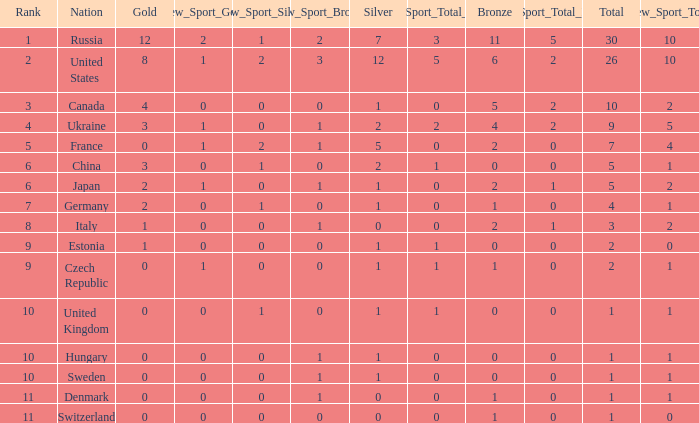Parse the table in full. {'header': ['Rank', 'Nation', 'Gold', 'New_Sport_Gold', 'New_Sport_Silver', 'New_Sport_Bronze', 'Silver', 'New_Sport_Total_Silver', 'Bronze', 'New_Sport_Total_Bronze', 'Total', 'New_Sport_Total'], 'rows': [['1', 'Russia', '12', '2', '1', '2', '7', '3', '11', '5', '30', '10'], ['2', 'United States', '8', '1', '2', '3', '12', '5', '6', '2', '26', '10'], ['3', 'Canada', '4', '0', '0', '0', '1', '0', '5', '2', '10', '2'], ['4', 'Ukraine', '3', '1', '0', '1', '2', '2', '4', '2', '9', '5'], ['5', 'France', '0', '1', '2', '1', '5', '0', '2', '0', '7', '4'], ['6', 'China', '3', '0', '1', '0', '2', '1', '0', '0', '5', '1'], ['6', 'Japan', '2', '1', '0', '1', '1', '0', '2', '1', '5', '2'], ['7', 'Germany', '2', '0', '1', '0', '1', '0', '1', '0', '4', '1'], ['8', 'Italy', '1', '0', '0', '1', '0', '0', '2', '1', '3', '2'], ['9', 'Estonia', '1', '0', '0', '0', '1', '1', '0', '0', '2', '0'], ['9', 'Czech Republic', '0', '1', '0', '0', '1', '1', '1', '0', '2', '1'], ['10', 'United Kingdom', '0', '0', '1', '0', '1', '1', '0', '0', '1', '1'], ['10', 'Hungary', '0', '0', '0', '1', '1', '0', '0', '0', '1', '1'], ['10', 'Sweden', '0', '0', '0', '1', '1', '0', '0', '0', '1', '1'], ['11', 'Denmark', '0', '0', '0', '1', '0', '0', '1', '0', '1', '1'], ['11', 'Switzerland', '0', '0', '0', '0', '0', '0', '1', '0', '1', '0']]} What is the largest silver with Gold larger than 4, a Nation of united states, and a Total larger than 26? None. 